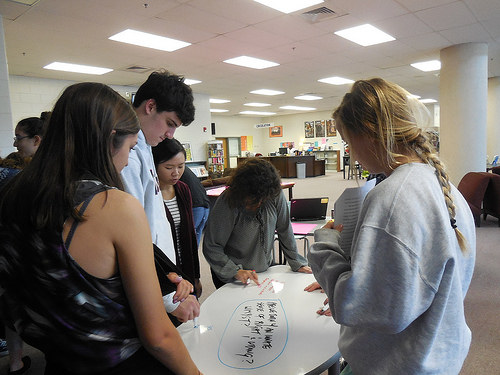<image>
Is the laptop on the table? No. The laptop is not positioned on the table. They may be near each other, but the laptop is not supported by or resting on top of the table. Where is the woman in relation to the table? Is it behind the table? Yes. From this viewpoint, the woman is positioned behind the table, with the table partially or fully occluding the woman. 